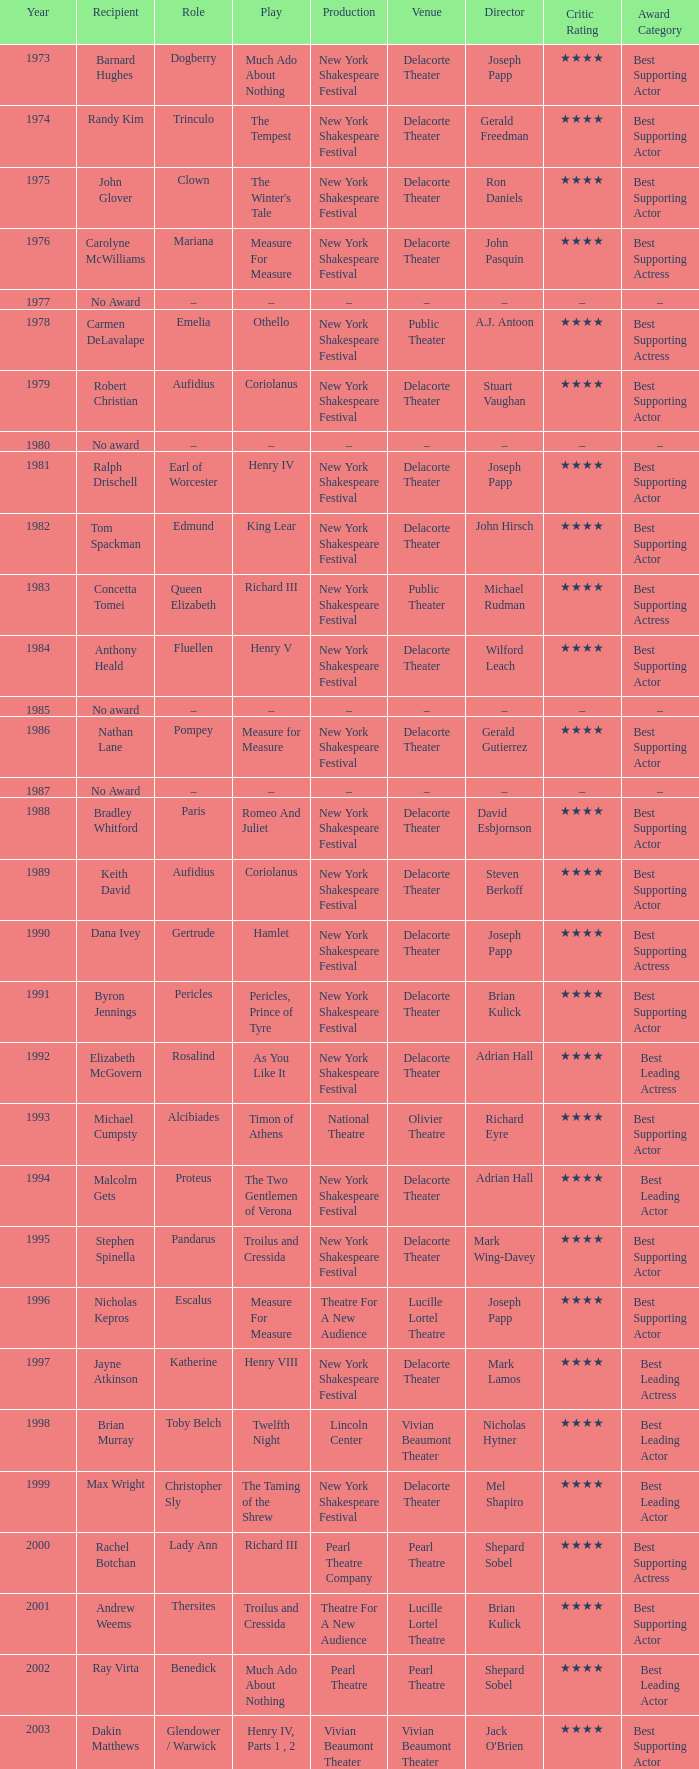Name the average year for much ado about nothing and recipient of ray virta 2002.0. 